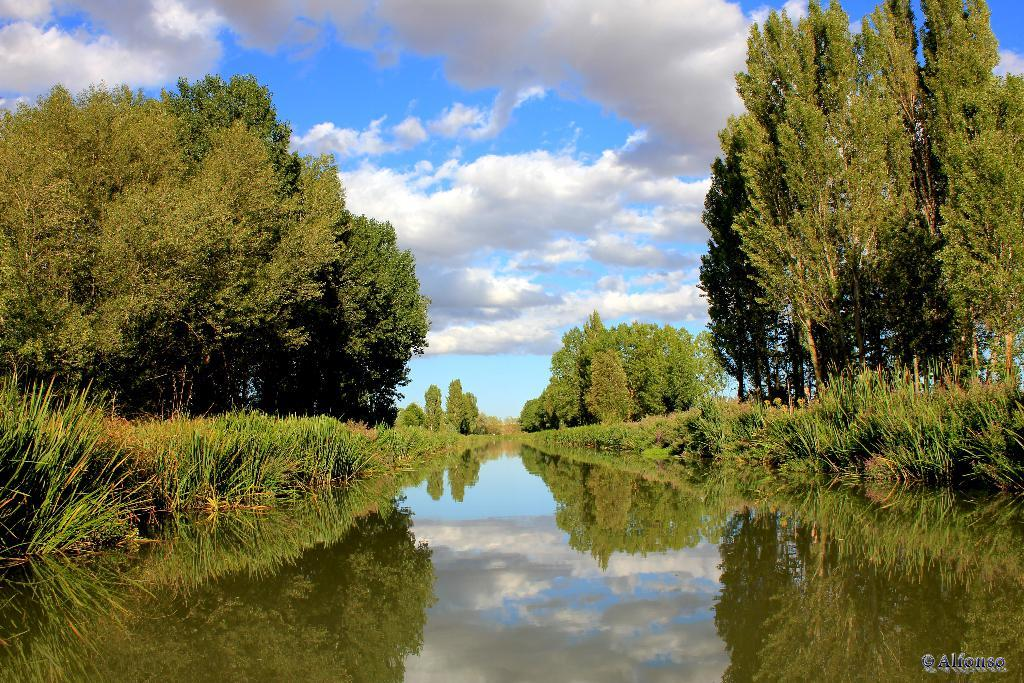What natural element can be seen in the image? Water is visible in the image. What type of vegetation is present in the image? There is grass and trees in the image. What is visible in the background of the image? The sky is visible in the image. What can be observed in the sky? Clouds are present in the sky. Where is the text located in the image? The text is in the bottom right side of the image. What type of beef is being served in the image? There is no beef present in the image; it features natural elements and text. What educational institution is depicted in the image? There is no educational institution depicted in the image; it features natural elements and text. 